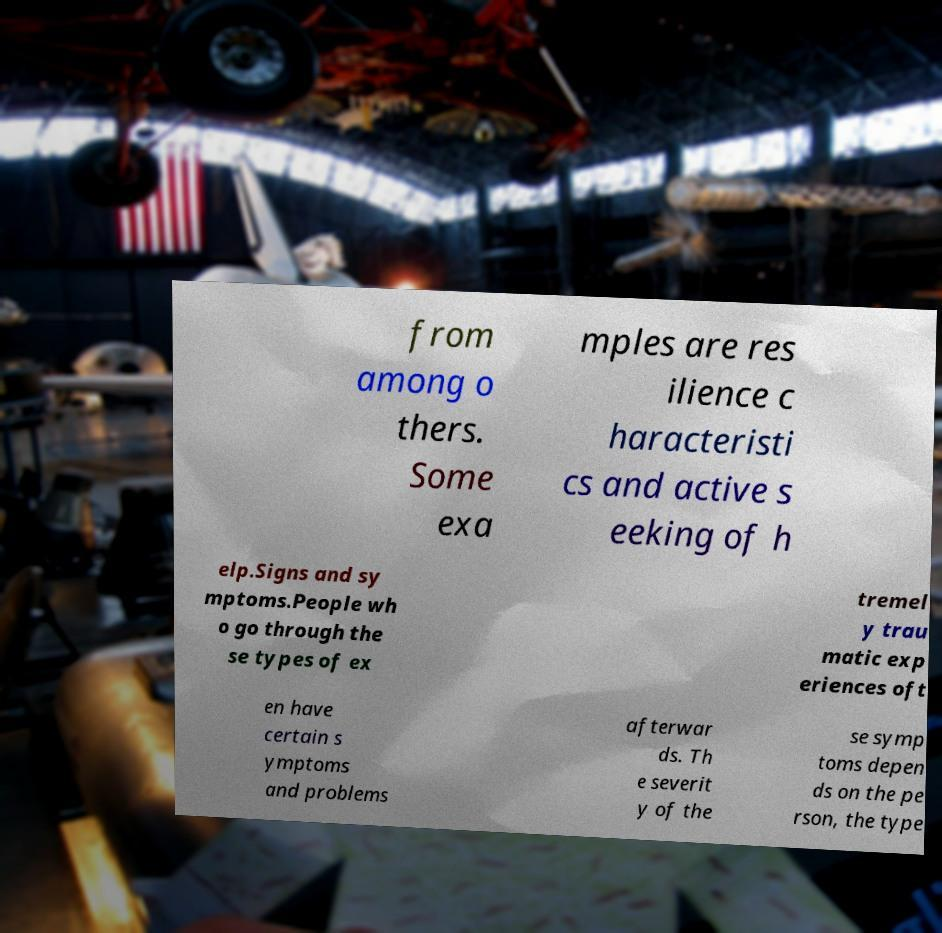Please identify and transcribe the text found in this image. from among o thers. Some exa mples are res ilience c haracteristi cs and active s eeking of h elp.Signs and sy mptoms.People wh o go through the se types of ex tremel y trau matic exp eriences oft en have certain s ymptoms and problems afterwar ds. Th e severit y of the se symp toms depen ds on the pe rson, the type 